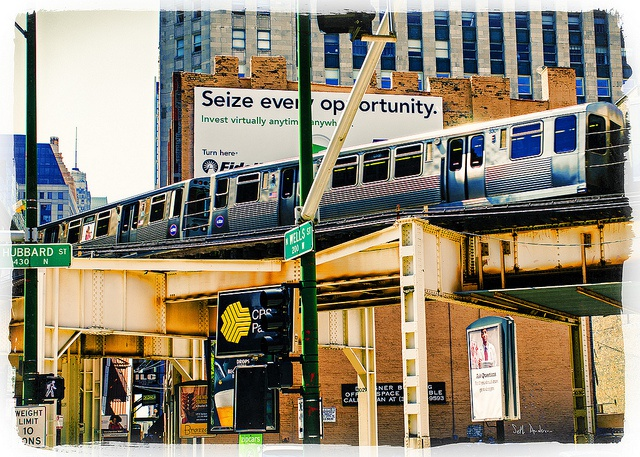Describe the objects in this image and their specific colors. I can see train in white, black, ivory, darkgray, and gray tones and traffic light in white, black, navy, lightgray, and tan tones in this image. 